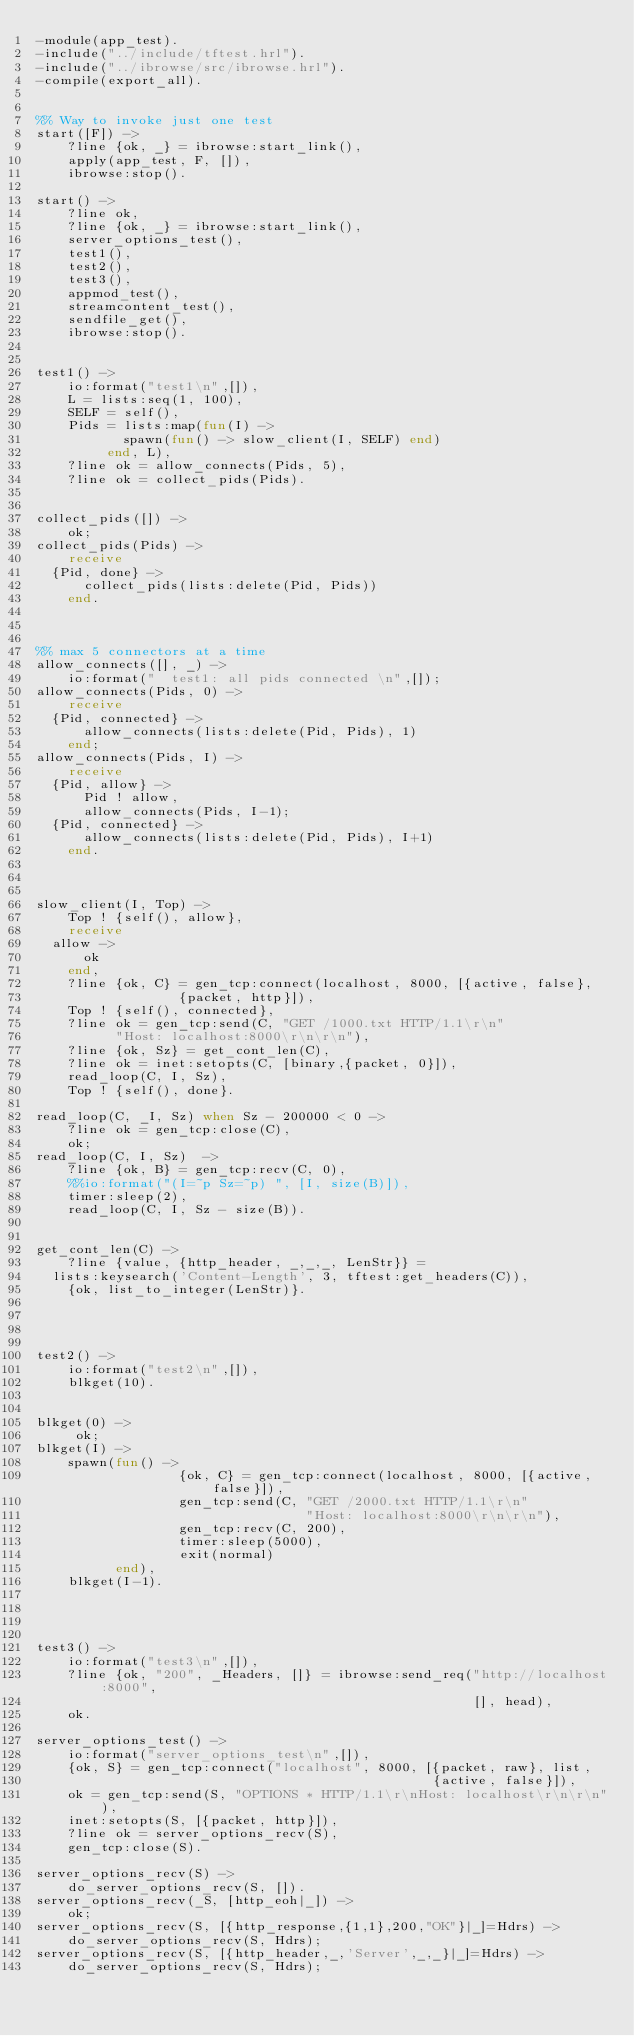<code> <loc_0><loc_0><loc_500><loc_500><_Erlang_>-module(app_test).
-include("../include/tftest.hrl").
-include("../ibrowse/src/ibrowse.hrl").
-compile(export_all).


%% Way to invoke just one test
start([F]) ->
    ?line {ok, _} = ibrowse:start_link(),
    apply(app_test, F, []),
    ibrowse:stop().

start() ->
    ?line ok,
    ?line {ok, _} = ibrowse:start_link(),
    server_options_test(),
    test1(),
    test2(),
    test3(),
    appmod_test(),
    streamcontent_test(),
    sendfile_get(),
    ibrowse:stop().


test1() ->
    io:format("test1\n",[]),
    L = lists:seq(1, 100),
    SELF = self(),
    Pids = lists:map(fun(I) ->
			     spawn(fun() -> slow_client(I, SELF) end)
		     end, L),
    ?line ok = allow_connects(Pids, 5),
    ?line ok = collect_pids(Pids).


collect_pids([]) ->
    ok;
collect_pids(Pids) ->
    receive
	{Pid, done} ->
	    collect_pids(lists:delete(Pid, Pids))
    end.



%% max 5 connectors at a time
allow_connects([], _) ->
    io:format("  test1: all pids connected \n",[]);
allow_connects(Pids, 0) ->
    receive
	{Pid, connected} ->
	    allow_connects(lists:delete(Pid, Pids), 1)
    end;
allow_connects(Pids, I) ->
    receive
	{Pid, allow} ->
	    Pid ! allow,
	    allow_connects(Pids, I-1);
	{Pid, connected} ->
	    allow_connects(lists:delete(Pid, Pids), I+1)
    end.



slow_client(I, Top) ->
    Top ! {self(), allow},
    receive
	allow ->
	    ok
    end,
    ?line {ok, C} = gen_tcp:connect(localhost, 8000, [{active, false},
						      {packet, http}]),
    Top ! {self(), connected},
    ?line ok = gen_tcp:send(C, "GET /1000.txt HTTP/1.1\r\n"
			    "Host: localhost:8000\r\n\r\n"),
    ?line {ok, Sz} = get_cont_len(C),
    ?line ok = inet:setopts(C, [binary,{packet, 0}]),
    read_loop(C, I, Sz),
    Top ! {self(), done}.

read_loop(C, _I, Sz) when Sz - 200000 < 0 ->
    ?line ok = gen_tcp:close(C),
    ok;
read_loop(C, I, Sz)  ->
    ?line {ok, B} = gen_tcp:recv(C, 0),
    %%io:format("(I=~p Sz=~p) ", [I, size(B)]),
    timer:sleep(2),
    read_loop(C, I, Sz - size(B)).


get_cont_len(C) ->
    ?line {value, {http_header, _,_,_, LenStr}} =
	lists:keysearch('Content-Length', 3, tftest:get_headers(C)),
    {ok, list_to_integer(LenStr)}.




test2() ->
    io:format("test2\n",[]),
    blkget(10).


blkget(0) ->
     ok;
blkget(I) ->
    spawn(fun() ->
                  {ok, C} = gen_tcp:connect(localhost, 8000, [{active, false}]),
                  gen_tcp:send(C, "GET /2000.txt HTTP/1.1\r\n"
                                  "Host: localhost:8000\r\n\r\n"),
                  gen_tcp:recv(C, 200),
                  timer:sleep(5000),
                  exit(normal)
          end),
    blkget(I-1).




test3() ->
    io:format("test3\n",[]),
    ?line {ok, "200", _Headers, []} = ibrowse:send_req("http://localhost:8000",
                                                       [], head),
    ok.

server_options_test() ->
    io:format("server_options_test\n",[]),
    {ok, S} = gen_tcp:connect("localhost", 8000, [{packet, raw}, list,
                                                  {active, false}]),
    ok = gen_tcp:send(S, "OPTIONS * HTTP/1.1\r\nHost: localhost\r\n\r\n"),
    inet:setopts(S, [{packet, http}]),
    ?line ok = server_options_recv(S),
    gen_tcp:close(S).

server_options_recv(S) ->
    do_server_options_recv(S, []).
server_options_recv(_S, [http_eoh|_]) ->
    ok;
server_options_recv(S, [{http_response,{1,1},200,"OK"}|_]=Hdrs) ->
    do_server_options_recv(S, Hdrs);
server_options_recv(S, [{http_header,_,'Server',_,_}|_]=Hdrs) ->
    do_server_options_recv(S, Hdrs);</code> 